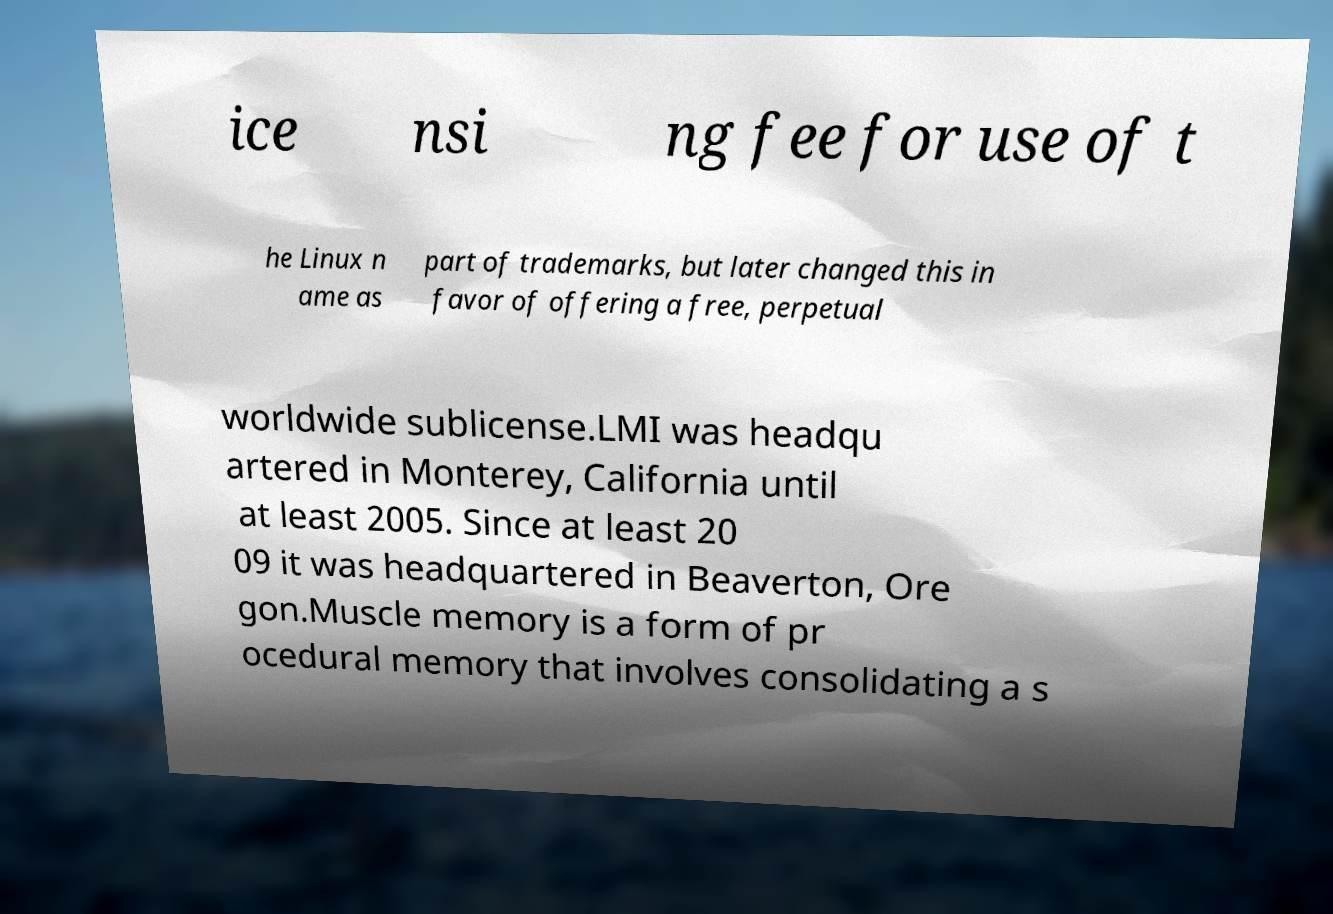Can you accurately transcribe the text from the provided image for me? ice nsi ng fee for use of t he Linux n ame as part of trademarks, but later changed this in favor of offering a free, perpetual worldwide sublicense.LMI was headqu artered in Monterey, California until at least 2005. Since at least 20 09 it was headquartered in Beaverton, Ore gon.Muscle memory is a form of pr ocedural memory that involves consolidating a s 